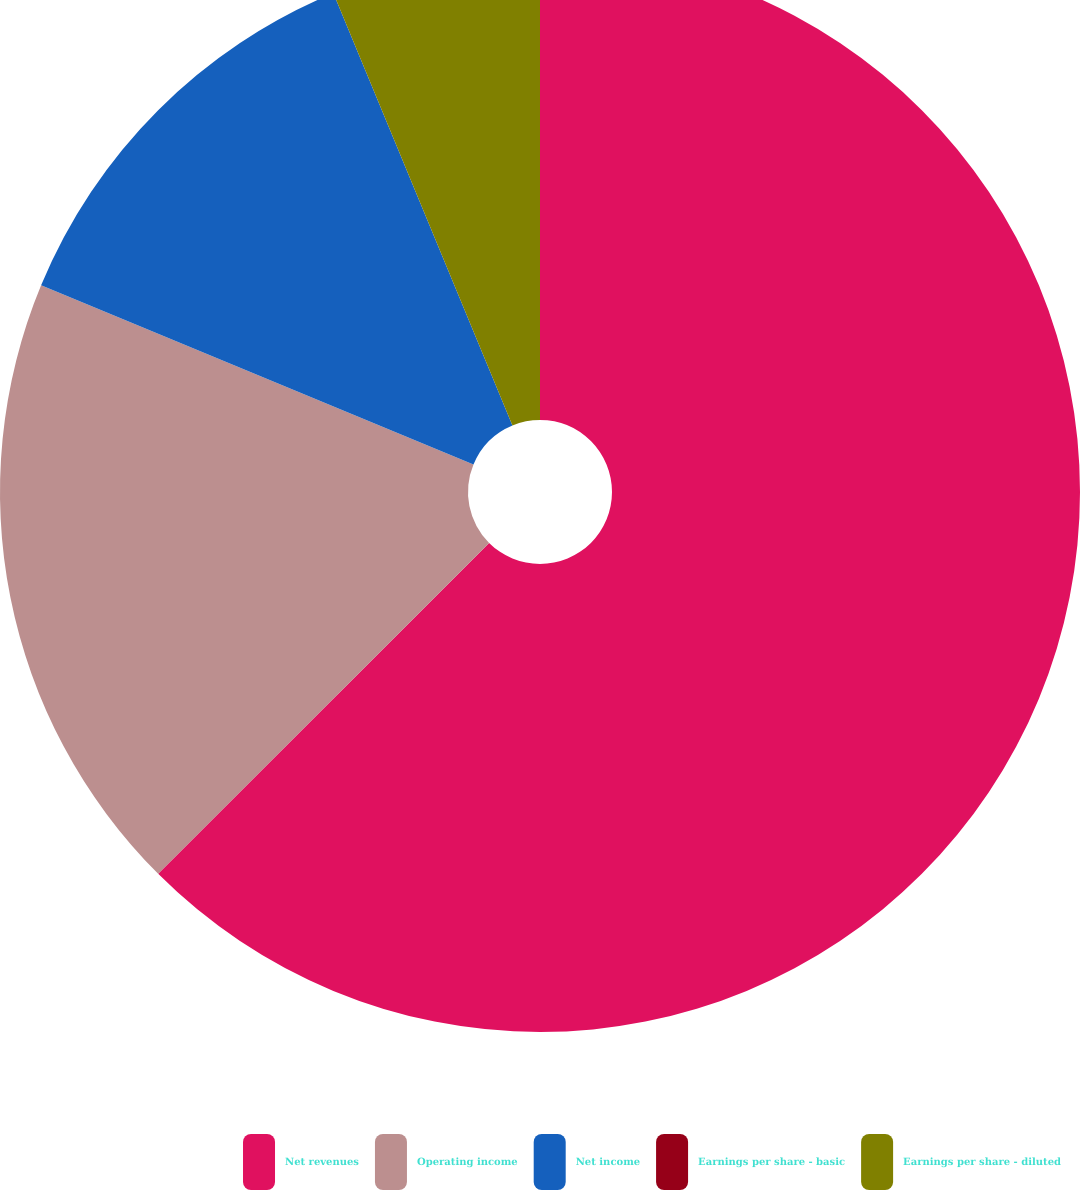Convert chart to OTSL. <chart><loc_0><loc_0><loc_500><loc_500><pie_chart><fcel>Net revenues<fcel>Operating income<fcel>Net income<fcel>Earnings per share - basic<fcel>Earnings per share - diluted<nl><fcel>62.5%<fcel>18.75%<fcel>12.5%<fcel>0.0%<fcel>6.25%<nl></chart> 